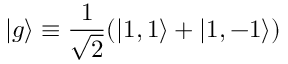Convert formula to latex. <formula><loc_0><loc_0><loc_500><loc_500>| g \rangle \equiv \frac { 1 } { \sqrt { 2 } } ( | 1 , 1 \rangle + | 1 , - 1 \rangle )</formula> 